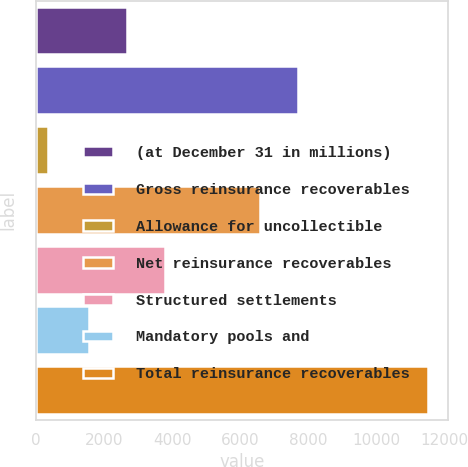<chart> <loc_0><loc_0><loc_500><loc_500><bar_chart><fcel>(at December 31 in millions)<fcel>Gross reinsurance recoverables<fcel>Allowance for uncollectible<fcel>Net reinsurance recoverables<fcel>Structured settlements<fcel>Mandatory pools and<fcel>Total reinsurance recoverables<nl><fcel>2683.6<fcel>7686.6<fcel>363<fcel>6571<fcel>3799.2<fcel>1568<fcel>11519<nl></chart> 